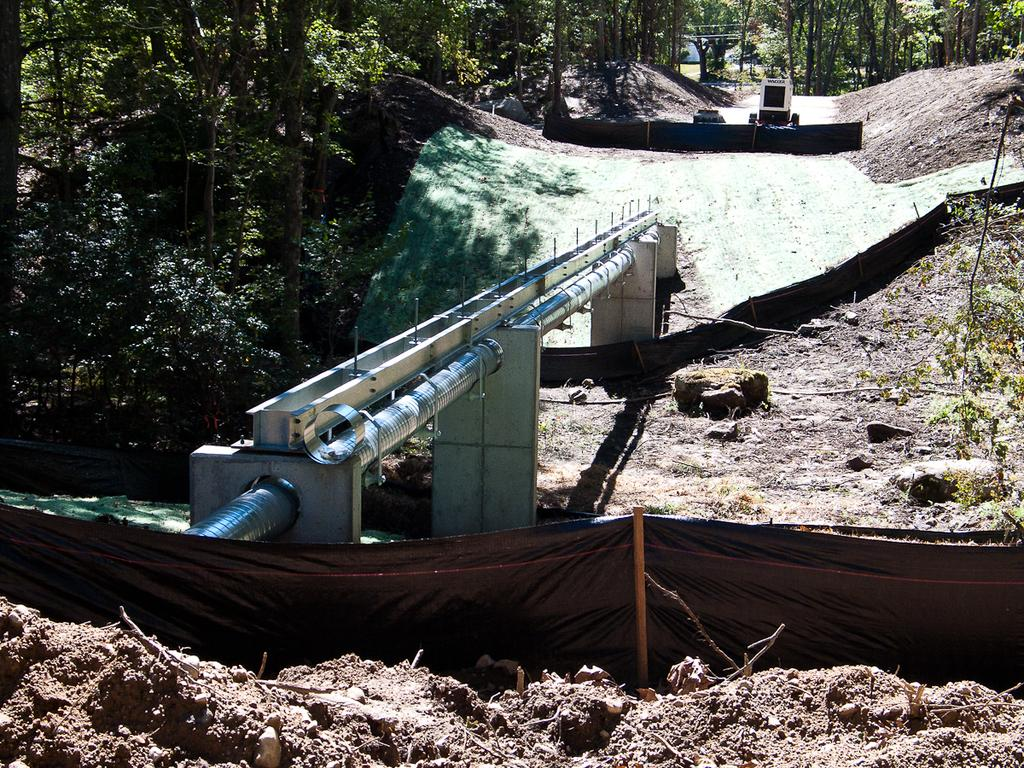What is the main structure in the center of the image? There is a concrete structure in the center of the image. What other object can be seen in the image? There is a pipe in the image. What type of terrain is visible in front of the image? There is sand in front of the image. What can be seen in the background of the image? There are trees in the background of the image. What story does the tongue tell in the image? There is no tongue present in the image, so no story can be told. 